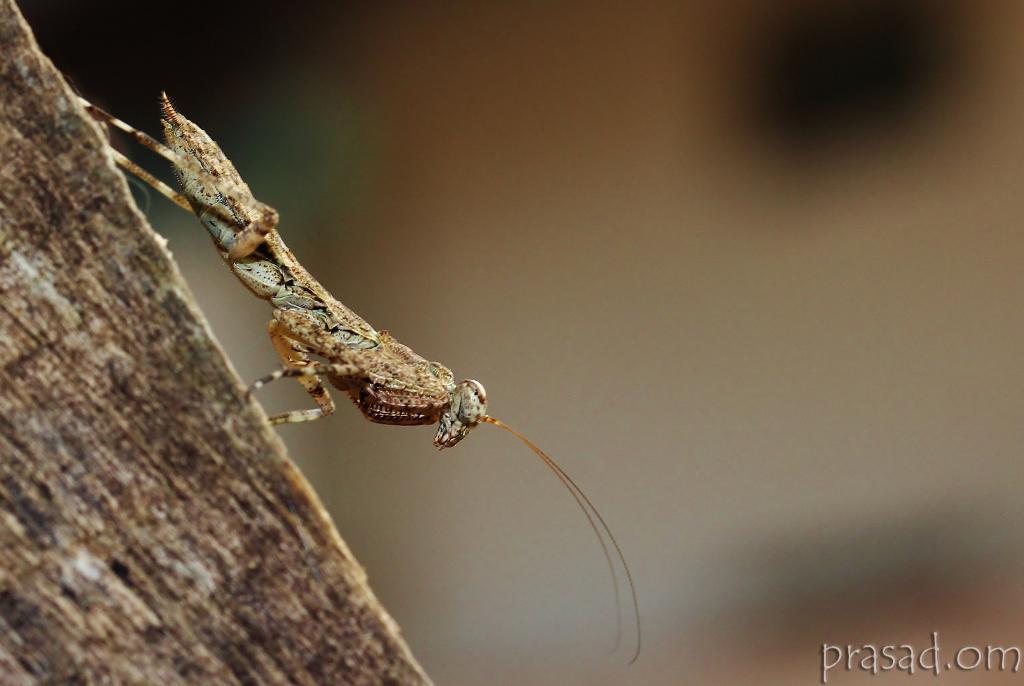In one or two sentences, can you explain what this image depicts? Here we can see an insect. This is water mark and there is a blur background. 